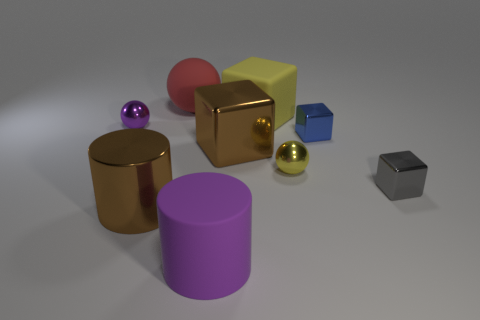Subtract all gray cubes. How many cubes are left? 3 Subtract 2 cubes. How many cubes are left? 2 Subtract all big yellow matte blocks. How many blocks are left? 3 Subtract all cyan cubes. Subtract all cyan cylinders. How many cubes are left? 4 Add 1 large blocks. How many objects exist? 10 Subtract all cylinders. How many objects are left? 7 Subtract all yellow cylinders. Subtract all large brown cylinders. How many objects are left? 8 Add 1 tiny blue shiny cubes. How many tiny blue shiny cubes are left? 2 Add 5 small cubes. How many small cubes exist? 7 Subtract 1 yellow cubes. How many objects are left? 8 